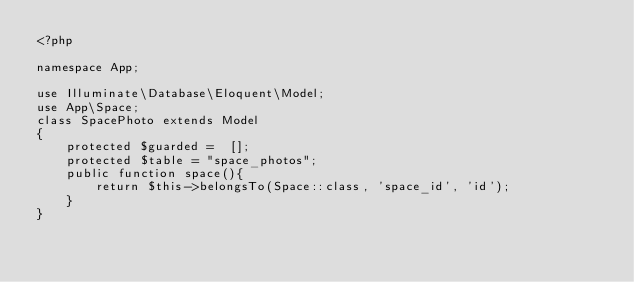<code> <loc_0><loc_0><loc_500><loc_500><_PHP_><?php

namespace App;

use Illuminate\Database\Eloquent\Model;
use App\Space;
class SpacePhoto extends Model
{
    protected $guarded =  [];
    protected $table = "space_photos";
    public function space(){
        return $this->belongsTo(Space::class, 'space_id', 'id');
    }
}
</code> 